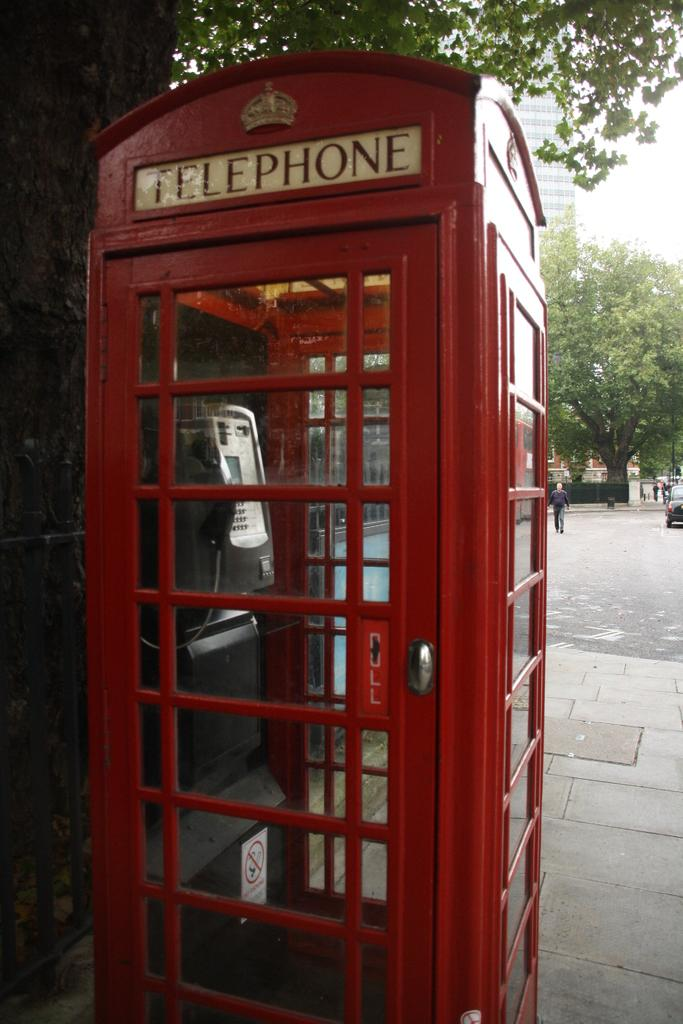<image>
Present a compact description of the photo's key features. An empty red telephone booth is on the sidewalk. 